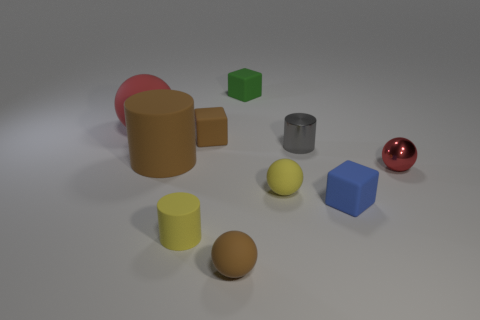What size is the matte cylinder that is in front of the tiny red shiny object?
Provide a succinct answer. Small. What is the shape of the tiny thing that is both right of the yellow sphere and in front of the tiny metal sphere?
Your response must be concise. Cube. There is a yellow object that is the same shape as the big red object; what size is it?
Provide a short and direct response. Small. What number of large objects have the same material as the big ball?
Your answer should be compact. 1. Do the large rubber cylinder and the rubber object that is in front of the small yellow cylinder have the same color?
Keep it short and to the point. Yes. Are there more blue rubber cubes than tiny yellow things?
Provide a succinct answer. No. What color is the large rubber cylinder?
Keep it short and to the point. Brown. There is a small rubber ball on the right side of the small brown ball; does it have the same color as the large rubber ball?
Make the answer very short. No. There is a small sphere that is the same color as the big matte cylinder; what material is it?
Provide a succinct answer. Rubber. How many tiny shiny cylinders are the same color as the shiny sphere?
Ensure brevity in your answer.  0. 